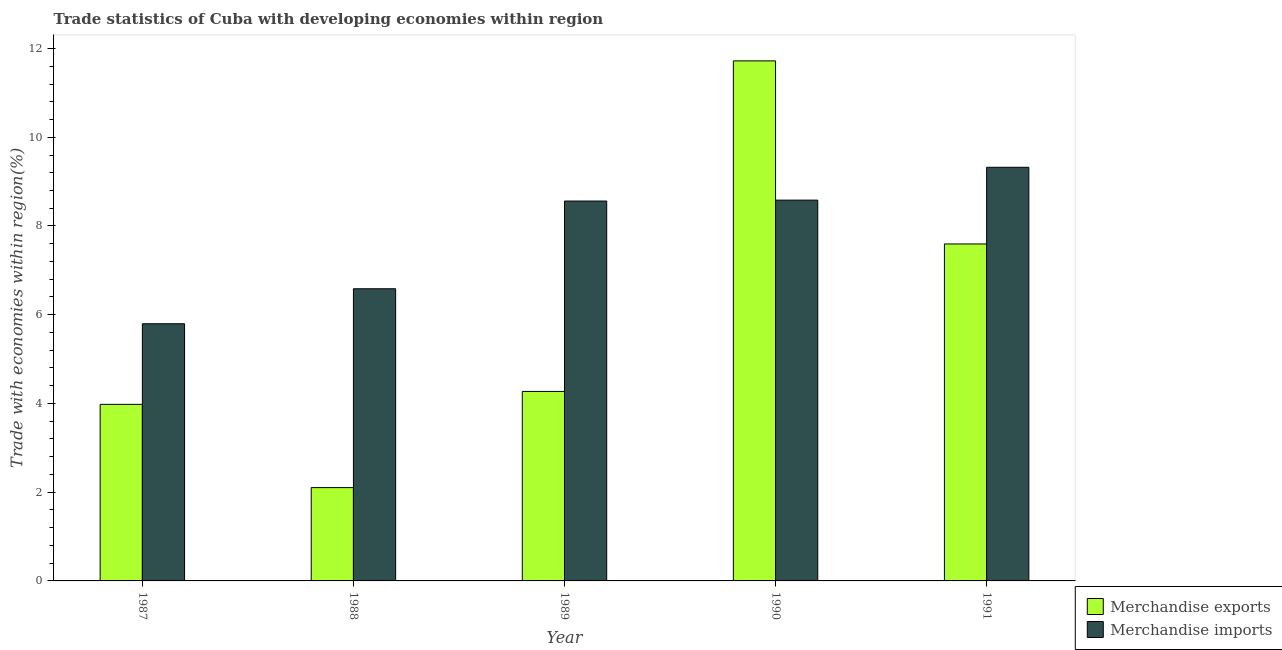How many different coloured bars are there?
Keep it short and to the point. 2. Are the number of bars per tick equal to the number of legend labels?
Ensure brevity in your answer.  Yes. How many bars are there on the 3rd tick from the left?
Offer a very short reply. 2. How many bars are there on the 1st tick from the right?
Make the answer very short. 2. What is the merchandise imports in 1988?
Your answer should be very brief. 6.59. Across all years, what is the maximum merchandise exports?
Your answer should be compact. 11.72. Across all years, what is the minimum merchandise exports?
Offer a very short reply. 2.1. What is the total merchandise exports in the graph?
Offer a very short reply. 29.67. What is the difference between the merchandise exports in 1987 and that in 1991?
Your answer should be very brief. -3.62. What is the difference between the merchandise imports in 1991 and the merchandise exports in 1989?
Ensure brevity in your answer.  0.76. What is the average merchandise imports per year?
Give a very brief answer. 7.77. What is the ratio of the merchandise imports in 1987 to that in 1989?
Give a very brief answer. 0.68. Is the difference between the merchandise imports in 1987 and 1988 greater than the difference between the merchandise exports in 1987 and 1988?
Offer a terse response. No. What is the difference between the highest and the second highest merchandise exports?
Give a very brief answer. 4.13. What is the difference between the highest and the lowest merchandise exports?
Make the answer very short. 9.62. In how many years, is the merchandise exports greater than the average merchandise exports taken over all years?
Your answer should be very brief. 2. Is the sum of the merchandise imports in 1987 and 1988 greater than the maximum merchandise exports across all years?
Offer a very short reply. Yes. What does the 1st bar from the left in 1990 represents?
Your answer should be compact. Merchandise exports. How many bars are there?
Provide a short and direct response. 10. Are all the bars in the graph horizontal?
Ensure brevity in your answer.  No. How many years are there in the graph?
Provide a short and direct response. 5. What is the difference between two consecutive major ticks on the Y-axis?
Provide a short and direct response. 2. Are the values on the major ticks of Y-axis written in scientific E-notation?
Offer a terse response. No. Where does the legend appear in the graph?
Your answer should be compact. Bottom right. How many legend labels are there?
Give a very brief answer. 2. What is the title of the graph?
Provide a succinct answer. Trade statistics of Cuba with developing economies within region. Does "Official aid received" appear as one of the legend labels in the graph?
Provide a succinct answer. No. What is the label or title of the Y-axis?
Provide a succinct answer. Trade with economies within region(%). What is the Trade with economies within region(%) of Merchandise exports in 1987?
Provide a short and direct response. 3.98. What is the Trade with economies within region(%) in Merchandise imports in 1987?
Your answer should be compact. 5.8. What is the Trade with economies within region(%) of Merchandise exports in 1988?
Keep it short and to the point. 2.1. What is the Trade with economies within region(%) in Merchandise imports in 1988?
Give a very brief answer. 6.59. What is the Trade with economies within region(%) of Merchandise exports in 1989?
Your answer should be very brief. 4.27. What is the Trade with economies within region(%) in Merchandise imports in 1989?
Your answer should be very brief. 8.56. What is the Trade with economies within region(%) of Merchandise exports in 1990?
Make the answer very short. 11.72. What is the Trade with economies within region(%) in Merchandise imports in 1990?
Give a very brief answer. 8.58. What is the Trade with economies within region(%) in Merchandise exports in 1991?
Your response must be concise. 7.59. What is the Trade with economies within region(%) of Merchandise imports in 1991?
Provide a succinct answer. 9.32. Across all years, what is the maximum Trade with economies within region(%) in Merchandise exports?
Your answer should be very brief. 11.72. Across all years, what is the maximum Trade with economies within region(%) of Merchandise imports?
Give a very brief answer. 9.32. Across all years, what is the minimum Trade with economies within region(%) of Merchandise exports?
Your answer should be compact. 2.1. Across all years, what is the minimum Trade with economies within region(%) in Merchandise imports?
Your response must be concise. 5.8. What is the total Trade with economies within region(%) of Merchandise exports in the graph?
Provide a succinct answer. 29.67. What is the total Trade with economies within region(%) of Merchandise imports in the graph?
Give a very brief answer. 38.85. What is the difference between the Trade with economies within region(%) of Merchandise exports in 1987 and that in 1988?
Make the answer very short. 1.88. What is the difference between the Trade with economies within region(%) of Merchandise imports in 1987 and that in 1988?
Offer a very short reply. -0.79. What is the difference between the Trade with economies within region(%) in Merchandise exports in 1987 and that in 1989?
Offer a very short reply. -0.29. What is the difference between the Trade with economies within region(%) in Merchandise imports in 1987 and that in 1989?
Provide a short and direct response. -2.77. What is the difference between the Trade with economies within region(%) in Merchandise exports in 1987 and that in 1990?
Your answer should be compact. -7.74. What is the difference between the Trade with economies within region(%) in Merchandise imports in 1987 and that in 1990?
Offer a very short reply. -2.79. What is the difference between the Trade with economies within region(%) in Merchandise exports in 1987 and that in 1991?
Ensure brevity in your answer.  -3.62. What is the difference between the Trade with economies within region(%) in Merchandise imports in 1987 and that in 1991?
Make the answer very short. -3.53. What is the difference between the Trade with economies within region(%) in Merchandise exports in 1988 and that in 1989?
Offer a very short reply. -2.17. What is the difference between the Trade with economies within region(%) in Merchandise imports in 1988 and that in 1989?
Give a very brief answer. -1.98. What is the difference between the Trade with economies within region(%) in Merchandise exports in 1988 and that in 1990?
Your answer should be very brief. -9.62. What is the difference between the Trade with economies within region(%) of Merchandise imports in 1988 and that in 1990?
Make the answer very short. -2. What is the difference between the Trade with economies within region(%) in Merchandise exports in 1988 and that in 1991?
Your response must be concise. -5.49. What is the difference between the Trade with economies within region(%) of Merchandise imports in 1988 and that in 1991?
Offer a very short reply. -2.74. What is the difference between the Trade with economies within region(%) of Merchandise exports in 1989 and that in 1990?
Your answer should be compact. -7.45. What is the difference between the Trade with economies within region(%) of Merchandise imports in 1989 and that in 1990?
Ensure brevity in your answer.  -0.02. What is the difference between the Trade with economies within region(%) in Merchandise exports in 1989 and that in 1991?
Your answer should be very brief. -3.32. What is the difference between the Trade with economies within region(%) of Merchandise imports in 1989 and that in 1991?
Make the answer very short. -0.76. What is the difference between the Trade with economies within region(%) of Merchandise exports in 1990 and that in 1991?
Your answer should be very brief. 4.13. What is the difference between the Trade with economies within region(%) of Merchandise imports in 1990 and that in 1991?
Your answer should be very brief. -0.74. What is the difference between the Trade with economies within region(%) in Merchandise exports in 1987 and the Trade with economies within region(%) in Merchandise imports in 1988?
Ensure brevity in your answer.  -2.61. What is the difference between the Trade with economies within region(%) in Merchandise exports in 1987 and the Trade with economies within region(%) in Merchandise imports in 1989?
Your answer should be compact. -4.58. What is the difference between the Trade with economies within region(%) of Merchandise exports in 1987 and the Trade with economies within region(%) of Merchandise imports in 1990?
Your answer should be very brief. -4.6. What is the difference between the Trade with economies within region(%) of Merchandise exports in 1987 and the Trade with economies within region(%) of Merchandise imports in 1991?
Make the answer very short. -5.34. What is the difference between the Trade with economies within region(%) in Merchandise exports in 1988 and the Trade with economies within region(%) in Merchandise imports in 1989?
Ensure brevity in your answer.  -6.46. What is the difference between the Trade with economies within region(%) of Merchandise exports in 1988 and the Trade with economies within region(%) of Merchandise imports in 1990?
Give a very brief answer. -6.48. What is the difference between the Trade with economies within region(%) in Merchandise exports in 1988 and the Trade with economies within region(%) in Merchandise imports in 1991?
Offer a very short reply. -7.22. What is the difference between the Trade with economies within region(%) of Merchandise exports in 1989 and the Trade with economies within region(%) of Merchandise imports in 1990?
Offer a very short reply. -4.31. What is the difference between the Trade with economies within region(%) of Merchandise exports in 1989 and the Trade with economies within region(%) of Merchandise imports in 1991?
Your answer should be very brief. -5.05. What is the difference between the Trade with economies within region(%) in Merchandise exports in 1990 and the Trade with economies within region(%) in Merchandise imports in 1991?
Provide a succinct answer. 2.4. What is the average Trade with economies within region(%) of Merchandise exports per year?
Give a very brief answer. 5.93. What is the average Trade with economies within region(%) in Merchandise imports per year?
Your answer should be very brief. 7.77. In the year 1987, what is the difference between the Trade with economies within region(%) of Merchandise exports and Trade with economies within region(%) of Merchandise imports?
Offer a terse response. -1.82. In the year 1988, what is the difference between the Trade with economies within region(%) of Merchandise exports and Trade with economies within region(%) of Merchandise imports?
Provide a succinct answer. -4.48. In the year 1989, what is the difference between the Trade with economies within region(%) of Merchandise exports and Trade with economies within region(%) of Merchandise imports?
Ensure brevity in your answer.  -4.29. In the year 1990, what is the difference between the Trade with economies within region(%) of Merchandise exports and Trade with economies within region(%) of Merchandise imports?
Your response must be concise. 3.14. In the year 1991, what is the difference between the Trade with economies within region(%) of Merchandise exports and Trade with economies within region(%) of Merchandise imports?
Offer a terse response. -1.73. What is the ratio of the Trade with economies within region(%) of Merchandise exports in 1987 to that in 1988?
Your response must be concise. 1.89. What is the ratio of the Trade with economies within region(%) of Merchandise imports in 1987 to that in 1988?
Provide a succinct answer. 0.88. What is the ratio of the Trade with economies within region(%) in Merchandise exports in 1987 to that in 1989?
Make the answer very short. 0.93. What is the ratio of the Trade with economies within region(%) of Merchandise imports in 1987 to that in 1989?
Your response must be concise. 0.68. What is the ratio of the Trade with economies within region(%) of Merchandise exports in 1987 to that in 1990?
Your answer should be very brief. 0.34. What is the ratio of the Trade with economies within region(%) of Merchandise imports in 1987 to that in 1990?
Offer a terse response. 0.68. What is the ratio of the Trade with economies within region(%) in Merchandise exports in 1987 to that in 1991?
Provide a short and direct response. 0.52. What is the ratio of the Trade with economies within region(%) of Merchandise imports in 1987 to that in 1991?
Provide a short and direct response. 0.62. What is the ratio of the Trade with economies within region(%) in Merchandise exports in 1988 to that in 1989?
Your response must be concise. 0.49. What is the ratio of the Trade with economies within region(%) of Merchandise imports in 1988 to that in 1989?
Keep it short and to the point. 0.77. What is the ratio of the Trade with economies within region(%) of Merchandise exports in 1988 to that in 1990?
Ensure brevity in your answer.  0.18. What is the ratio of the Trade with economies within region(%) of Merchandise imports in 1988 to that in 1990?
Your response must be concise. 0.77. What is the ratio of the Trade with economies within region(%) of Merchandise exports in 1988 to that in 1991?
Offer a very short reply. 0.28. What is the ratio of the Trade with economies within region(%) in Merchandise imports in 1988 to that in 1991?
Offer a terse response. 0.71. What is the ratio of the Trade with economies within region(%) in Merchandise exports in 1989 to that in 1990?
Provide a succinct answer. 0.36. What is the ratio of the Trade with economies within region(%) in Merchandise exports in 1989 to that in 1991?
Your answer should be very brief. 0.56. What is the ratio of the Trade with economies within region(%) in Merchandise imports in 1989 to that in 1991?
Make the answer very short. 0.92. What is the ratio of the Trade with economies within region(%) in Merchandise exports in 1990 to that in 1991?
Offer a terse response. 1.54. What is the ratio of the Trade with economies within region(%) of Merchandise imports in 1990 to that in 1991?
Your answer should be very brief. 0.92. What is the difference between the highest and the second highest Trade with economies within region(%) of Merchandise exports?
Your answer should be compact. 4.13. What is the difference between the highest and the second highest Trade with economies within region(%) of Merchandise imports?
Provide a short and direct response. 0.74. What is the difference between the highest and the lowest Trade with economies within region(%) in Merchandise exports?
Give a very brief answer. 9.62. What is the difference between the highest and the lowest Trade with economies within region(%) in Merchandise imports?
Your response must be concise. 3.53. 